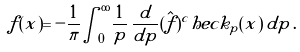<formula> <loc_0><loc_0><loc_500><loc_500>f ( x ) = - \frac { 1 } \pi { \int ^ { \infty } _ { 0 } } \frac { 1 } { p } \, \frac { d } { d p } ( \hat { f } ) ^ { c } h e c k _ { p } ( x ) \, d p \, .</formula> 